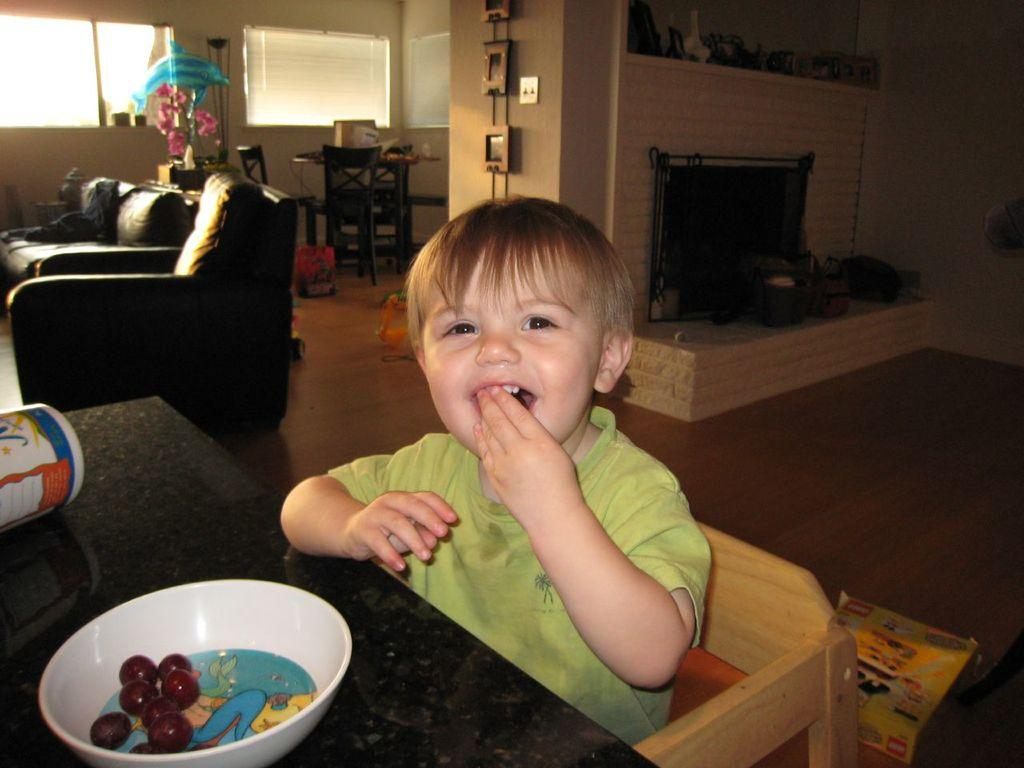Who is the main subject in the image? There is a boy in the image. What is the boy doing in the image? The boy is sitting on a chair. What is in front of the boy? There is a table in front of the boy. What is on the table? There is a white color bowl on the table. What type of furniture is visible in the image besides the chair? There are sofas in the image. Can you see the father of the boy in the image? There is no information about the boy's father in the image or the provided facts. Is the boy smiling in the image? The provided facts do not mention the boy's facial expression, so we cannot determine if he is smiling or not. 